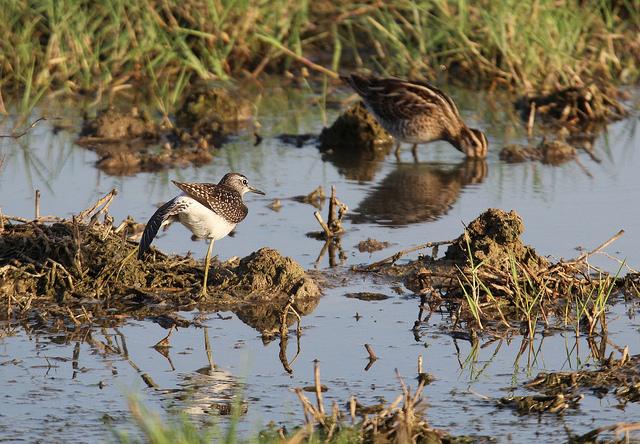What is the bird hiding in?
Write a very short answer. Water. Does the water have ripples?
Short answer required. Yes. What is the bird in the background doing?
Short answer required. Drinking. Is it in the water?
Write a very short answer. Yes. Why does the nest look like a mess?
Quick response, please. Yes. What is just underneath the surface of the water?
Write a very short answer. Mud. Are the ducklings eating?
Be succinct. Yes. Would most people consider this a good place to swim?
Quick response, please. No. 